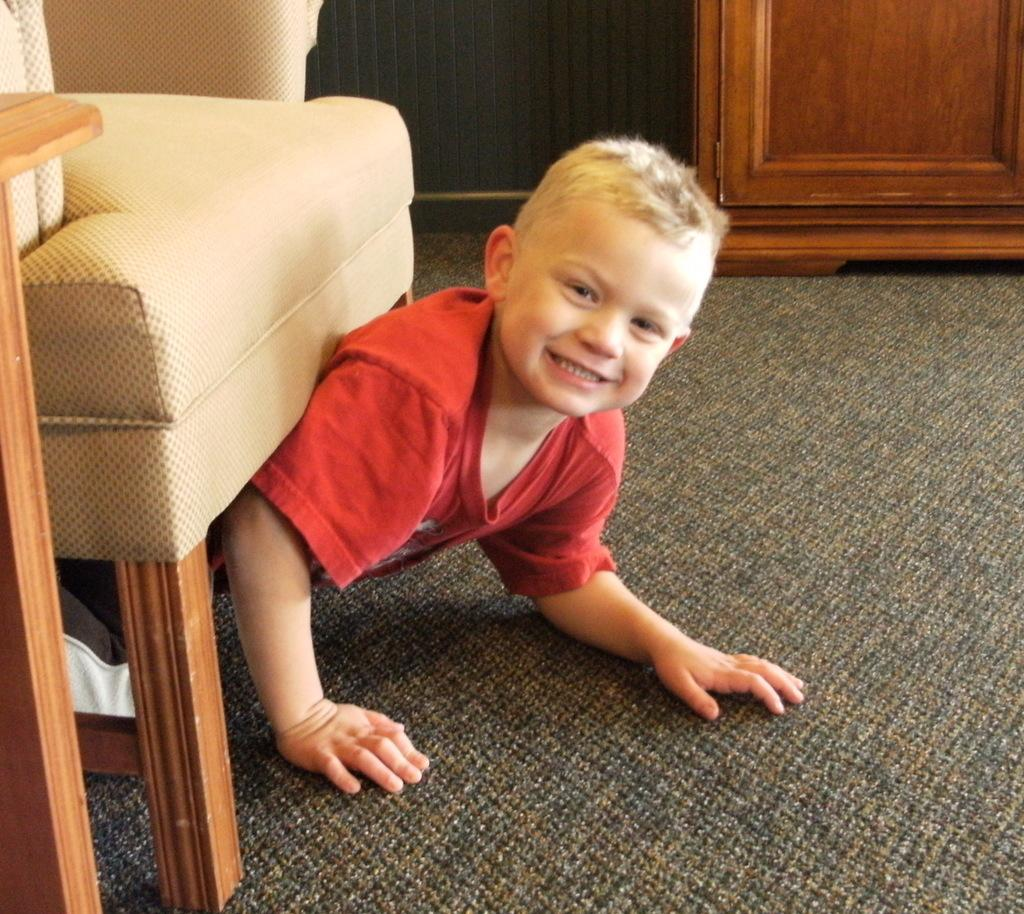What is the main subject of the image? The main subject of the image is a kid. What is the kid wearing in the image? The kid is wearing a red shirt in the image. What action is the kid performing in the image? The kid is crawling under a chair in the image. What is on the ground in the image? The ground has a mat on it in the image. What type of pen is the kid holding in the image? There is no pen present in the image; the kid is crawling under a chair while wearing a red shirt. 